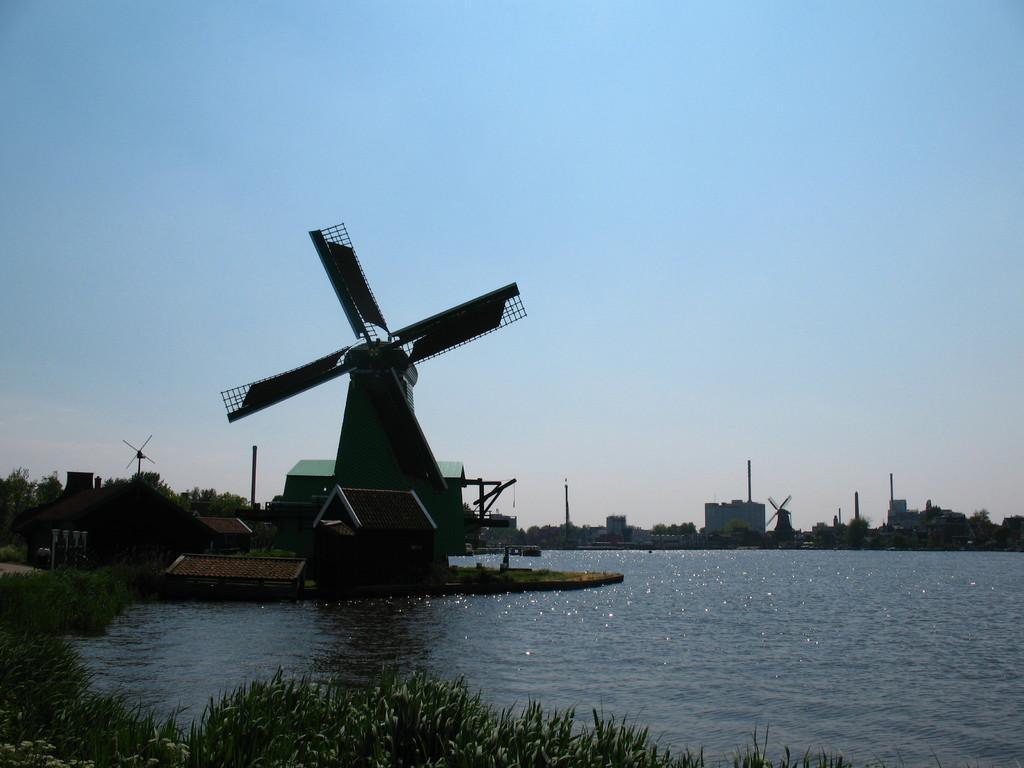Can you describe this image briefly? This is an outside view. At the bottom there is a sea and I can see few plants. In the middle of the image there are few windmills, poles and buildings and also there are many trees. At the top of the image I can see the sky. 